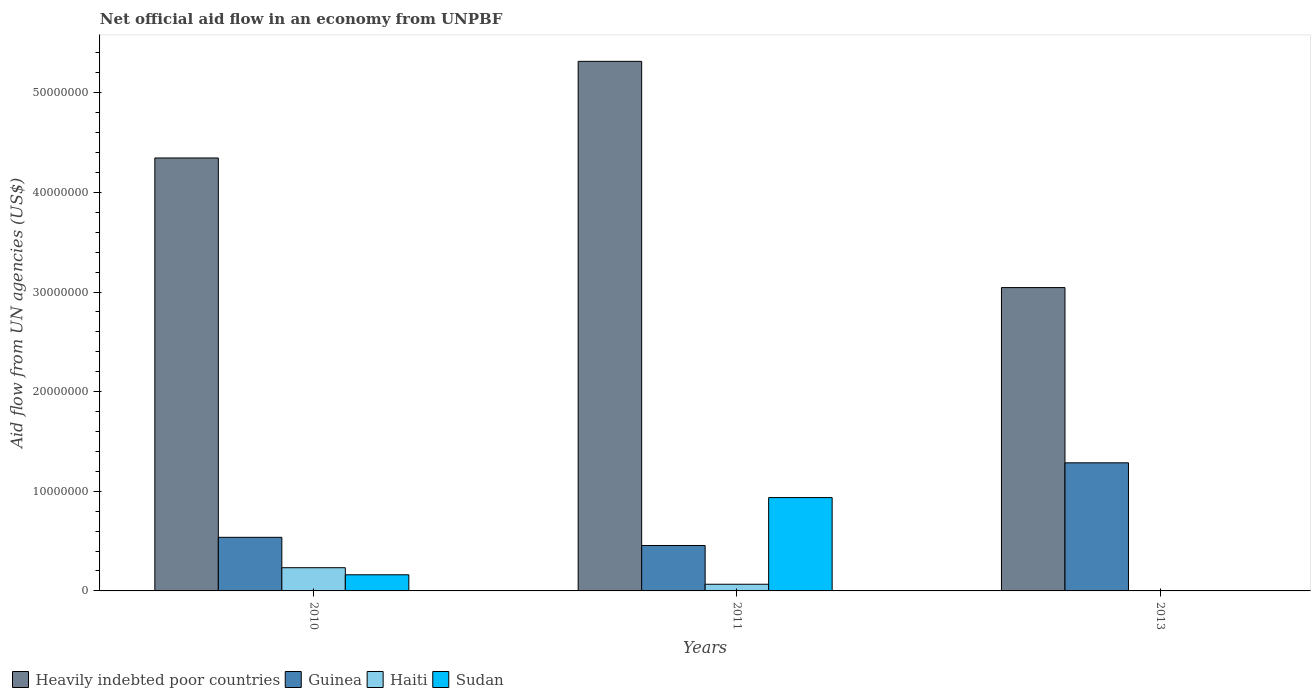Are the number of bars per tick equal to the number of legend labels?
Give a very brief answer. No. How many bars are there on the 2nd tick from the left?
Make the answer very short. 4. How many bars are there on the 2nd tick from the right?
Give a very brief answer. 4. What is the label of the 1st group of bars from the left?
Keep it short and to the point. 2010. In how many cases, is the number of bars for a given year not equal to the number of legend labels?
Your answer should be very brief. 1. What is the net official aid flow in Sudan in 2010?
Your answer should be compact. 1.62e+06. Across all years, what is the maximum net official aid flow in Haiti?
Give a very brief answer. 2.33e+06. What is the total net official aid flow in Haiti in the graph?
Your answer should be compact. 3.02e+06. What is the difference between the net official aid flow in Sudan in 2010 and that in 2011?
Offer a very short reply. -7.75e+06. What is the difference between the net official aid flow in Heavily indebted poor countries in 2011 and the net official aid flow in Haiti in 2013?
Give a very brief answer. 5.31e+07. What is the average net official aid flow in Guinea per year?
Keep it short and to the point. 7.60e+06. In the year 2011, what is the difference between the net official aid flow in Heavily indebted poor countries and net official aid flow in Sudan?
Offer a very short reply. 4.38e+07. In how many years, is the net official aid flow in Heavily indebted poor countries greater than 50000000 US$?
Provide a succinct answer. 1. What is the ratio of the net official aid flow in Sudan in 2010 to that in 2011?
Offer a terse response. 0.17. Is the net official aid flow in Guinea in 2011 less than that in 2013?
Offer a very short reply. Yes. Is the difference between the net official aid flow in Heavily indebted poor countries in 2010 and 2011 greater than the difference between the net official aid flow in Sudan in 2010 and 2011?
Make the answer very short. No. What is the difference between the highest and the second highest net official aid flow in Haiti?
Ensure brevity in your answer.  1.66e+06. What is the difference between the highest and the lowest net official aid flow in Heavily indebted poor countries?
Give a very brief answer. 2.27e+07. In how many years, is the net official aid flow in Haiti greater than the average net official aid flow in Haiti taken over all years?
Offer a terse response. 1. Is it the case that in every year, the sum of the net official aid flow in Sudan and net official aid flow in Heavily indebted poor countries is greater than the sum of net official aid flow in Guinea and net official aid flow in Haiti?
Provide a succinct answer. Yes. How many bars are there?
Give a very brief answer. 11. Are all the bars in the graph horizontal?
Your answer should be very brief. No. How many years are there in the graph?
Make the answer very short. 3. Does the graph contain any zero values?
Offer a terse response. Yes. Does the graph contain grids?
Offer a terse response. No. How many legend labels are there?
Offer a very short reply. 4. How are the legend labels stacked?
Make the answer very short. Horizontal. What is the title of the graph?
Your response must be concise. Net official aid flow in an economy from UNPBF. What is the label or title of the Y-axis?
Offer a terse response. Aid flow from UN agencies (US$). What is the Aid flow from UN agencies (US$) of Heavily indebted poor countries in 2010?
Ensure brevity in your answer.  4.35e+07. What is the Aid flow from UN agencies (US$) of Guinea in 2010?
Offer a terse response. 5.38e+06. What is the Aid flow from UN agencies (US$) of Haiti in 2010?
Your answer should be very brief. 2.33e+06. What is the Aid flow from UN agencies (US$) in Sudan in 2010?
Offer a terse response. 1.62e+06. What is the Aid flow from UN agencies (US$) in Heavily indebted poor countries in 2011?
Your answer should be very brief. 5.32e+07. What is the Aid flow from UN agencies (US$) of Guinea in 2011?
Offer a terse response. 4.56e+06. What is the Aid flow from UN agencies (US$) of Haiti in 2011?
Provide a short and direct response. 6.70e+05. What is the Aid flow from UN agencies (US$) of Sudan in 2011?
Make the answer very short. 9.37e+06. What is the Aid flow from UN agencies (US$) in Heavily indebted poor countries in 2013?
Your answer should be compact. 3.04e+07. What is the Aid flow from UN agencies (US$) in Guinea in 2013?
Your answer should be compact. 1.29e+07. What is the Aid flow from UN agencies (US$) of Haiti in 2013?
Your answer should be very brief. 2.00e+04. Across all years, what is the maximum Aid flow from UN agencies (US$) in Heavily indebted poor countries?
Ensure brevity in your answer.  5.32e+07. Across all years, what is the maximum Aid flow from UN agencies (US$) of Guinea?
Your answer should be compact. 1.29e+07. Across all years, what is the maximum Aid flow from UN agencies (US$) in Haiti?
Give a very brief answer. 2.33e+06. Across all years, what is the maximum Aid flow from UN agencies (US$) in Sudan?
Make the answer very short. 9.37e+06. Across all years, what is the minimum Aid flow from UN agencies (US$) in Heavily indebted poor countries?
Keep it short and to the point. 3.04e+07. Across all years, what is the minimum Aid flow from UN agencies (US$) of Guinea?
Your answer should be very brief. 4.56e+06. Across all years, what is the minimum Aid flow from UN agencies (US$) of Haiti?
Your answer should be very brief. 2.00e+04. What is the total Aid flow from UN agencies (US$) in Heavily indebted poor countries in the graph?
Keep it short and to the point. 1.27e+08. What is the total Aid flow from UN agencies (US$) of Guinea in the graph?
Ensure brevity in your answer.  2.28e+07. What is the total Aid flow from UN agencies (US$) of Haiti in the graph?
Keep it short and to the point. 3.02e+06. What is the total Aid flow from UN agencies (US$) of Sudan in the graph?
Ensure brevity in your answer.  1.10e+07. What is the difference between the Aid flow from UN agencies (US$) of Heavily indebted poor countries in 2010 and that in 2011?
Provide a succinct answer. -9.70e+06. What is the difference between the Aid flow from UN agencies (US$) in Guinea in 2010 and that in 2011?
Your response must be concise. 8.20e+05. What is the difference between the Aid flow from UN agencies (US$) in Haiti in 2010 and that in 2011?
Your response must be concise. 1.66e+06. What is the difference between the Aid flow from UN agencies (US$) in Sudan in 2010 and that in 2011?
Make the answer very short. -7.75e+06. What is the difference between the Aid flow from UN agencies (US$) of Heavily indebted poor countries in 2010 and that in 2013?
Provide a short and direct response. 1.30e+07. What is the difference between the Aid flow from UN agencies (US$) of Guinea in 2010 and that in 2013?
Offer a terse response. -7.48e+06. What is the difference between the Aid flow from UN agencies (US$) in Haiti in 2010 and that in 2013?
Make the answer very short. 2.31e+06. What is the difference between the Aid flow from UN agencies (US$) in Heavily indebted poor countries in 2011 and that in 2013?
Provide a short and direct response. 2.27e+07. What is the difference between the Aid flow from UN agencies (US$) in Guinea in 2011 and that in 2013?
Ensure brevity in your answer.  -8.30e+06. What is the difference between the Aid flow from UN agencies (US$) in Haiti in 2011 and that in 2013?
Provide a short and direct response. 6.50e+05. What is the difference between the Aid flow from UN agencies (US$) of Heavily indebted poor countries in 2010 and the Aid flow from UN agencies (US$) of Guinea in 2011?
Give a very brief answer. 3.89e+07. What is the difference between the Aid flow from UN agencies (US$) in Heavily indebted poor countries in 2010 and the Aid flow from UN agencies (US$) in Haiti in 2011?
Offer a very short reply. 4.28e+07. What is the difference between the Aid flow from UN agencies (US$) of Heavily indebted poor countries in 2010 and the Aid flow from UN agencies (US$) of Sudan in 2011?
Provide a short and direct response. 3.41e+07. What is the difference between the Aid flow from UN agencies (US$) of Guinea in 2010 and the Aid flow from UN agencies (US$) of Haiti in 2011?
Ensure brevity in your answer.  4.71e+06. What is the difference between the Aid flow from UN agencies (US$) in Guinea in 2010 and the Aid flow from UN agencies (US$) in Sudan in 2011?
Your answer should be very brief. -3.99e+06. What is the difference between the Aid flow from UN agencies (US$) of Haiti in 2010 and the Aid flow from UN agencies (US$) of Sudan in 2011?
Give a very brief answer. -7.04e+06. What is the difference between the Aid flow from UN agencies (US$) of Heavily indebted poor countries in 2010 and the Aid flow from UN agencies (US$) of Guinea in 2013?
Keep it short and to the point. 3.06e+07. What is the difference between the Aid flow from UN agencies (US$) of Heavily indebted poor countries in 2010 and the Aid flow from UN agencies (US$) of Haiti in 2013?
Offer a terse response. 4.34e+07. What is the difference between the Aid flow from UN agencies (US$) of Guinea in 2010 and the Aid flow from UN agencies (US$) of Haiti in 2013?
Ensure brevity in your answer.  5.36e+06. What is the difference between the Aid flow from UN agencies (US$) of Heavily indebted poor countries in 2011 and the Aid flow from UN agencies (US$) of Guinea in 2013?
Offer a terse response. 4.03e+07. What is the difference between the Aid flow from UN agencies (US$) of Heavily indebted poor countries in 2011 and the Aid flow from UN agencies (US$) of Haiti in 2013?
Keep it short and to the point. 5.31e+07. What is the difference between the Aid flow from UN agencies (US$) in Guinea in 2011 and the Aid flow from UN agencies (US$) in Haiti in 2013?
Give a very brief answer. 4.54e+06. What is the average Aid flow from UN agencies (US$) of Heavily indebted poor countries per year?
Keep it short and to the point. 4.24e+07. What is the average Aid flow from UN agencies (US$) of Guinea per year?
Give a very brief answer. 7.60e+06. What is the average Aid flow from UN agencies (US$) of Haiti per year?
Your answer should be compact. 1.01e+06. What is the average Aid flow from UN agencies (US$) of Sudan per year?
Make the answer very short. 3.66e+06. In the year 2010, what is the difference between the Aid flow from UN agencies (US$) in Heavily indebted poor countries and Aid flow from UN agencies (US$) in Guinea?
Keep it short and to the point. 3.81e+07. In the year 2010, what is the difference between the Aid flow from UN agencies (US$) in Heavily indebted poor countries and Aid flow from UN agencies (US$) in Haiti?
Offer a very short reply. 4.11e+07. In the year 2010, what is the difference between the Aid flow from UN agencies (US$) in Heavily indebted poor countries and Aid flow from UN agencies (US$) in Sudan?
Make the answer very short. 4.18e+07. In the year 2010, what is the difference between the Aid flow from UN agencies (US$) of Guinea and Aid flow from UN agencies (US$) of Haiti?
Your response must be concise. 3.05e+06. In the year 2010, what is the difference between the Aid flow from UN agencies (US$) in Guinea and Aid flow from UN agencies (US$) in Sudan?
Your response must be concise. 3.76e+06. In the year 2010, what is the difference between the Aid flow from UN agencies (US$) of Haiti and Aid flow from UN agencies (US$) of Sudan?
Provide a short and direct response. 7.10e+05. In the year 2011, what is the difference between the Aid flow from UN agencies (US$) in Heavily indebted poor countries and Aid flow from UN agencies (US$) in Guinea?
Give a very brief answer. 4.86e+07. In the year 2011, what is the difference between the Aid flow from UN agencies (US$) in Heavily indebted poor countries and Aid flow from UN agencies (US$) in Haiti?
Make the answer very short. 5.25e+07. In the year 2011, what is the difference between the Aid flow from UN agencies (US$) in Heavily indebted poor countries and Aid flow from UN agencies (US$) in Sudan?
Make the answer very short. 4.38e+07. In the year 2011, what is the difference between the Aid flow from UN agencies (US$) in Guinea and Aid flow from UN agencies (US$) in Haiti?
Provide a succinct answer. 3.89e+06. In the year 2011, what is the difference between the Aid flow from UN agencies (US$) in Guinea and Aid flow from UN agencies (US$) in Sudan?
Your answer should be compact. -4.81e+06. In the year 2011, what is the difference between the Aid flow from UN agencies (US$) of Haiti and Aid flow from UN agencies (US$) of Sudan?
Offer a very short reply. -8.70e+06. In the year 2013, what is the difference between the Aid flow from UN agencies (US$) of Heavily indebted poor countries and Aid flow from UN agencies (US$) of Guinea?
Your response must be concise. 1.76e+07. In the year 2013, what is the difference between the Aid flow from UN agencies (US$) in Heavily indebted poor countries and Aid flow from UN agencies (US$) in Haiti?
Your answer should be very brief. 3.04e+07. In the year 2013, what is the difference between the Aid flow from UN agencies (US$) of Guinea and Aid flow from UN agencies (US$) of Haiti?
Give a very brief answer. 1.28e+07. What is the ratio of the Aid flow from UN agencies (US$) of Heavily indebted poor countries in 2010 to that in 2011?
Provide a short and direct response. 0.82. What is the ratio of the Aid flow from UN agencies (US$) of Guinea in 2010 to that in 2011?
Offer a very short reply. 1.18. What is the ratio of the Aid flow from UN agencies (US$) in Haiti in 2010 to that in 2011?
Ensure brevity in your answer.  3.48. What is the ratio of the Aid flow from UN agencies (US$) of Sudan in 2010 to that in 2011?
Make the answer very short. 0.17. What is the ratio of the Aid flow from UN agencies (US$) of Heavily indebted poor countries in 2010 to that in 2013?
Offer a terse response. 1.43. What is the ratio of the Aid flow from UN agencies (US$) in Guinea in 2010 to that in 2013?
Provide a short and direct response. 0.42. What is the ratio of the Aid flow from UN agencies (US$) of Haiti in 2010 to that in 2013?
Your response must be concise. 116.5. What is the ratio of the Aid flow from UN agencies (US$) of Heavily indebted poor countries in 2011 to that in 2013?
Give a very brief answer. 1.75. What is the ratio of the Aid flow from UN agencies (US$) of Guinea in 2011 to that in 2013?
Provide a succinct answer. 0.35. What is the ratio of the Aid flow from UN agencies (US$) of Haiti in 2011 to that in 2013?
Offer a very short reply. 33.5. What is the difference between the highest and the second highest Aid flow from UN agencies (US$) in Heavily indebted poor countries?
Your answer should be compact. 9.70e+06. What is the difference between the highest and the second highest Aid flow from UN agencies (US$) in Guinea?
Provide a succinct answer. 7.48e+06. What is the difference between the highest and the second highest Aid flow from UN agencies (US$) in Haiti?
Your answer should be very brief. 1.66e+06. What is the difference between the highest and the lowest Aid flow from UN agencies (US$) in Heavily indebted poor countries?
Ensure brevity in your answer.  2.27e+07. What is the difference between the highest and the lowest Aid flow from UN agencies (US$) of Guinea?
Give a very brief answer. 8.30e+06. What is the difference between the highest and the lowest Aid flow from UN agencies (US$) of Haiti?
Your answer should be compact. 2.31e+06. What is the difference between the highest and the lowest Aid flow from UN agencies (US$) in Sudan?
Provide a short and direct response. 9.37e+06. 